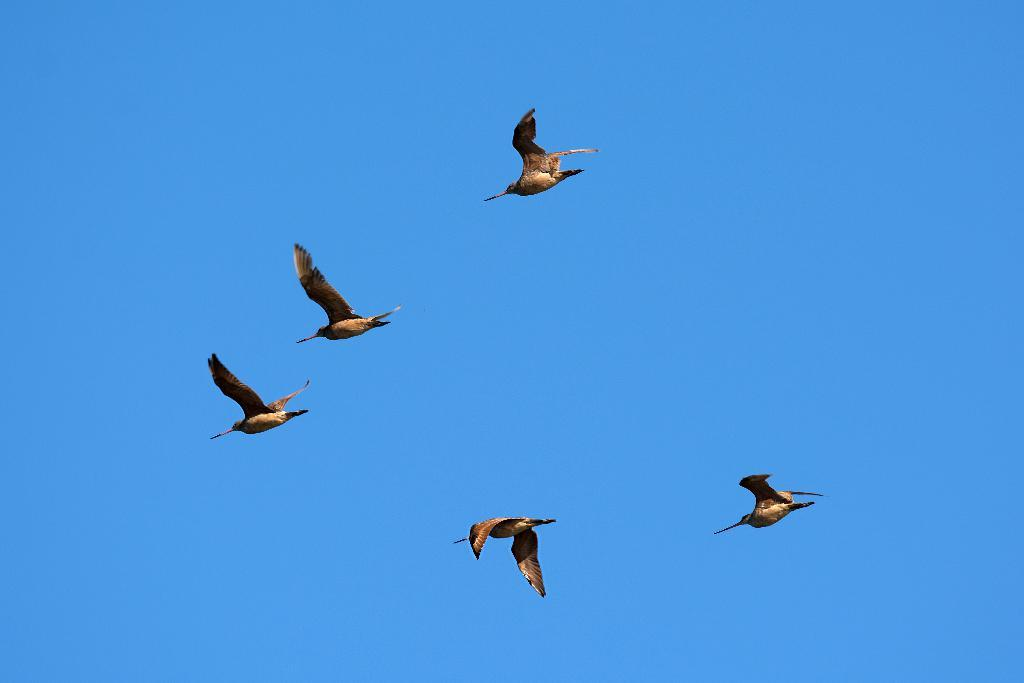What is the main subject of the image? The main subject of the image is a group of birds. What are the birds doing in the image? The birds are flying in the sky. How many goats can be seen sleeping in the image? There are no goats present in the image, and therefore no sleeping goats can be observed. 